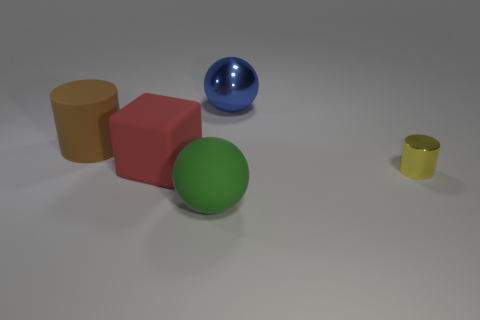Add 5 yellow shiny things. How many objects exist? 10 Subtract all cylinders. How many objects are left? 3 Subtract all tiny rubber cylinders. Subtract all large brown rubber objects. How many objects are left? 4 Add 1 big rubber spheres. How many big rubber spheres are left? 2 Add 4 yellow shiny cylinders. How many yellow shiny cylinders exist? 5 Subtract 0 purple cubes. How many objects are left? 5 